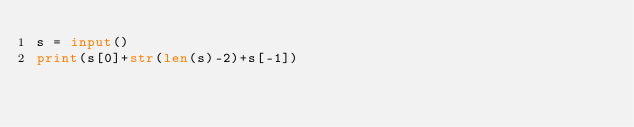Convert code to text. <code><loc_0><loc_0><loc_500><loc_500><_Python_>s = input()
print(s[0]+str(len(s)-2)+s[-1])</code> 